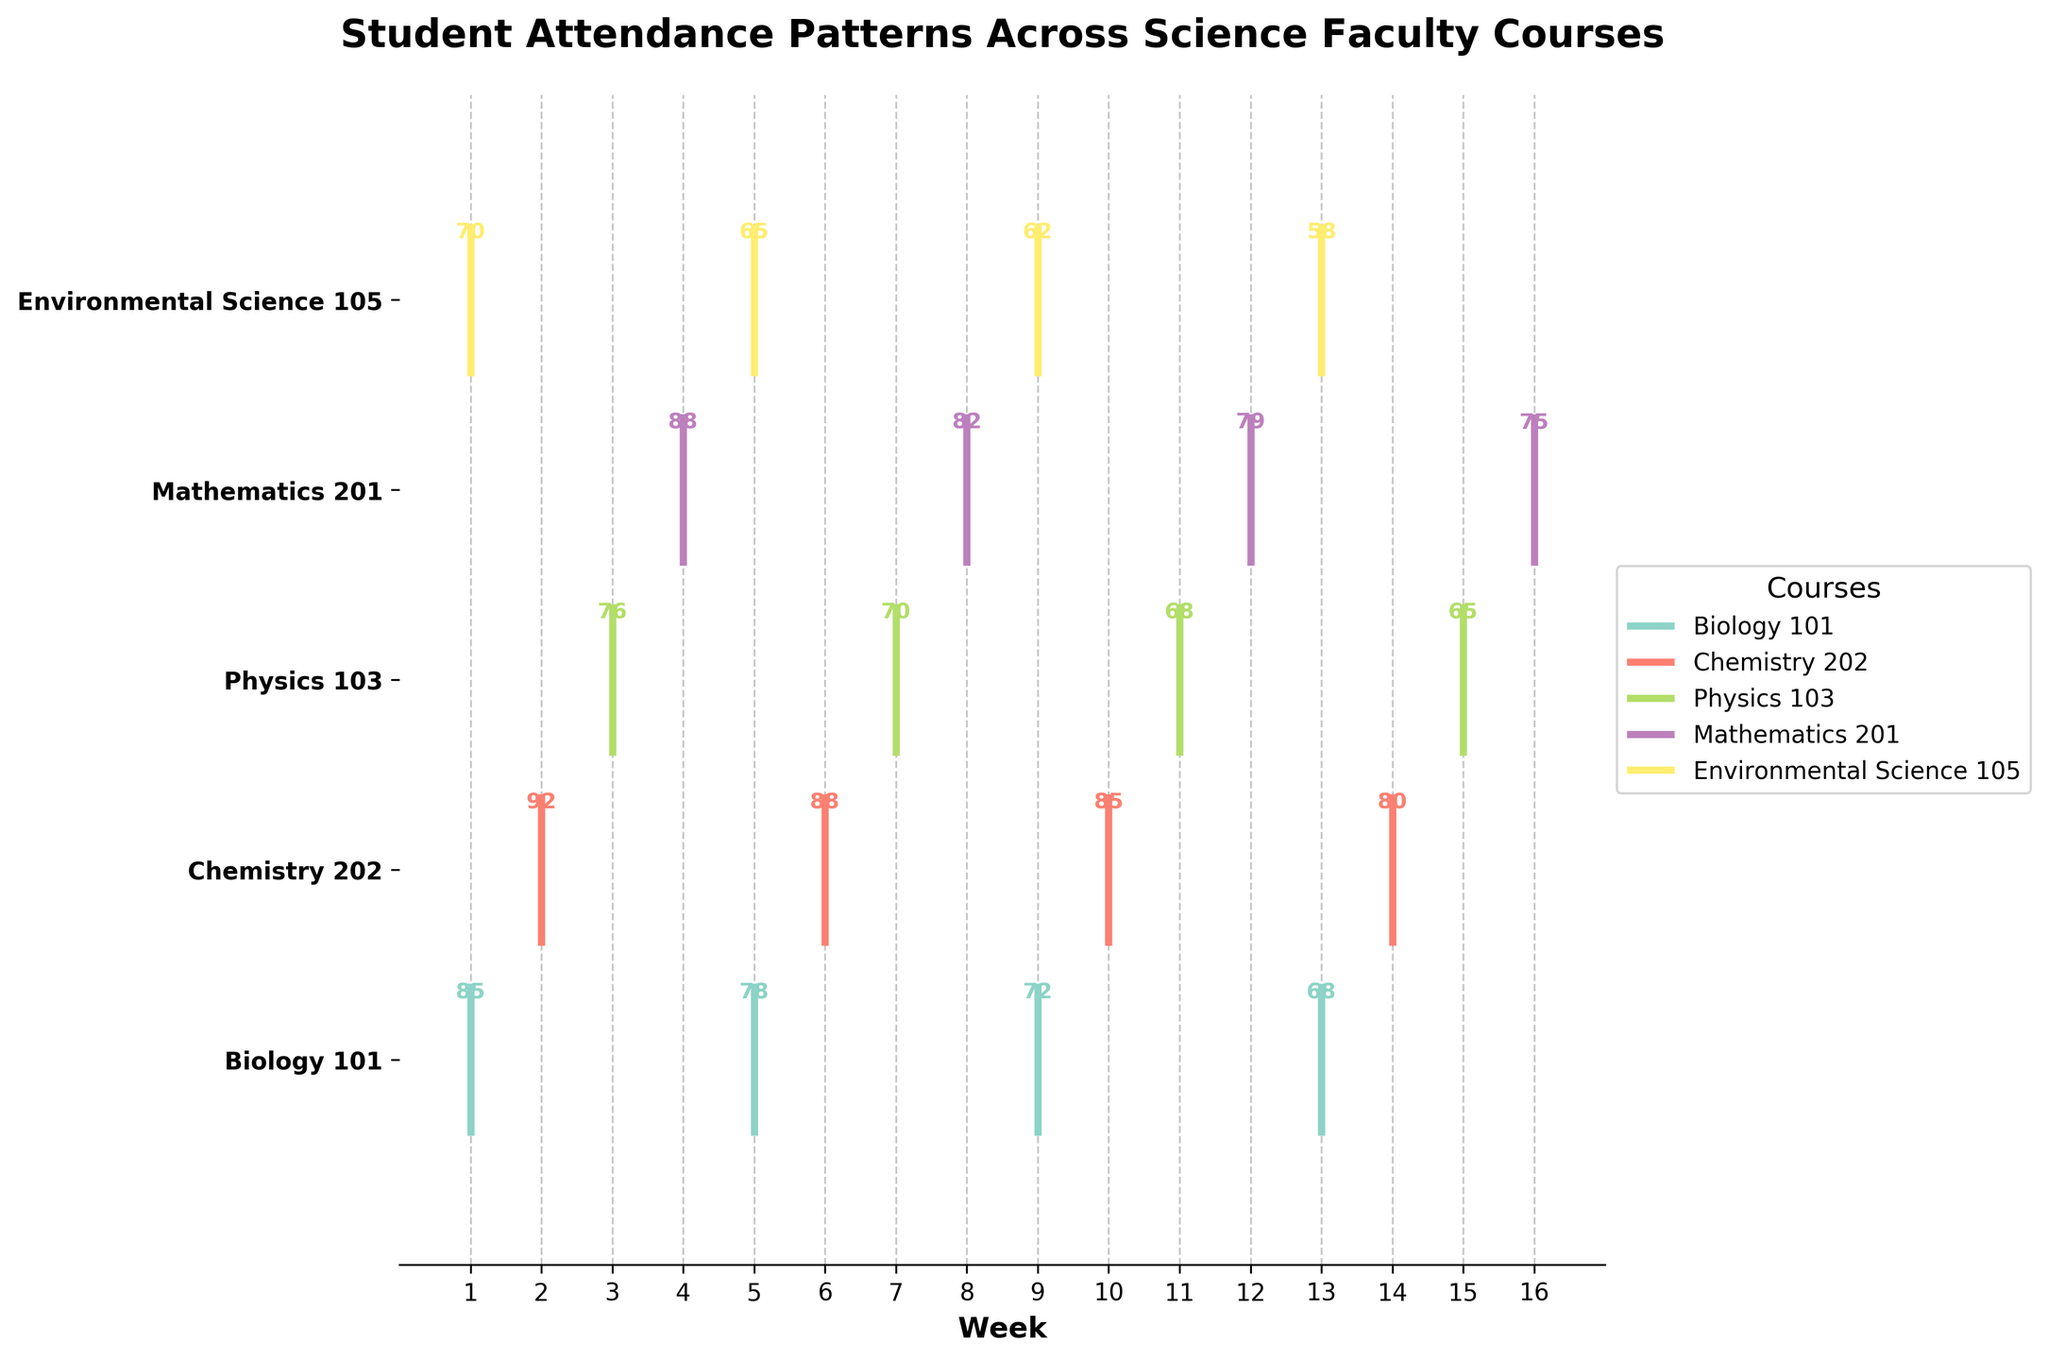What's the title of the figure? The title is written at the top of the figure.
Answer: Student Attendance Patterns Across Science Faculty Courses Which course has the highest attendance in Week 12? Look for the data point labeled with '79' under Week 12, which corresponds to Mathematics 201.
Answer: Mathematics 201 Which week's attendance values are displayed for Environmental Science 105? The weeks marked with attendance data for Environmental Science 105 are: Weeks 1, 5, 9, and 13.
Answer: Weeks 1, 5, 9, 13 How many courses are displayed in the figure? Count the number of unique y-ticks, which are labeled with course names. The figure shows five courses.
Answer: 5 In which week did Chemistry 202 have its highest attendance? The highest attendance for Chemistry 202 is 92, which is annotated in Week 2.
Answer: Week 2 Which course has the lowest attendance in any given week over the semester? The lowest attendance value is 58 in Week 13 for Environmental Science 105.
Answer: Environmental Science 105 How does the final week's attendance compare between Biology 101 and Physics 103? Compare the attendance values in the final weeks of both courses. Biology 101 has 68 in Week 13, and Physics 103 has 65 in Week 15. Therefore, Biology 101 has higher final-week attendance.
Answer: Biology 101 has higher final-week attendance Which are the two lowest attendance values recorded in the plot, and which courses do they belong to? The two lowest attendance values are 58 and 62. These correspond to Environmental Science 105 in Weeks 13 and 9, respectively.
Answer: 58 and 62, Environmental Science 105 What is the average attendance for Physics 103? Add up all attendance values for Physics 103 (76 + 70 + 68 + 65) and divide by the number of weeks (4). Sum is 279; divide by 4 gives the average 69.75.
Answer: 69.75 What trend can you observe in Mathematics 201 attendance over the semester? Attendance in Mathematics 201 starts at 88, decreases to 82 (Week 8), then 79 (Week 12), and finally 75 (Week 16). The trend is a steady decrease.
Answer: Steady decrease 